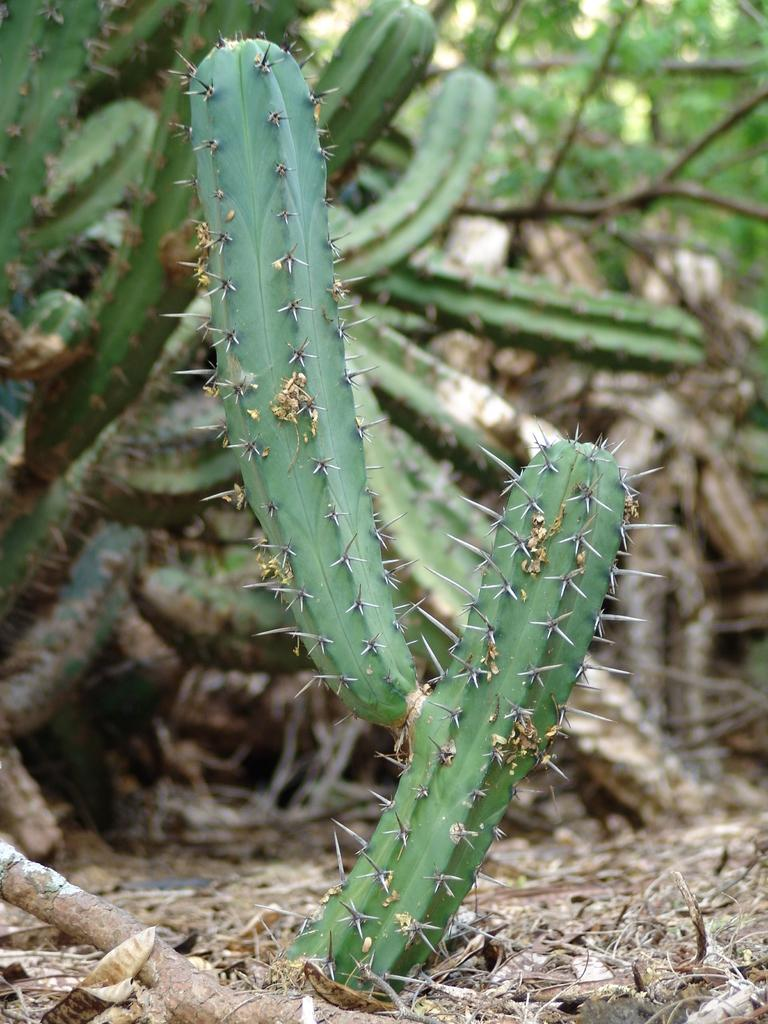What type of plants can be seen in the image? There are cactus plants and trees in the image. What part of the plants is visible in the image? There are leaves in the image. What else can be seen on the ground in the image? There are sticks on the ground in the image. What type of thumb can be seen in the image? There is no thumb present in the image. Is the image taken in space? The image does not depict a space setting; it features plants and sticks on the ground. What type of metal is visible in the image? There is no metal, including zinc, present in the image. 